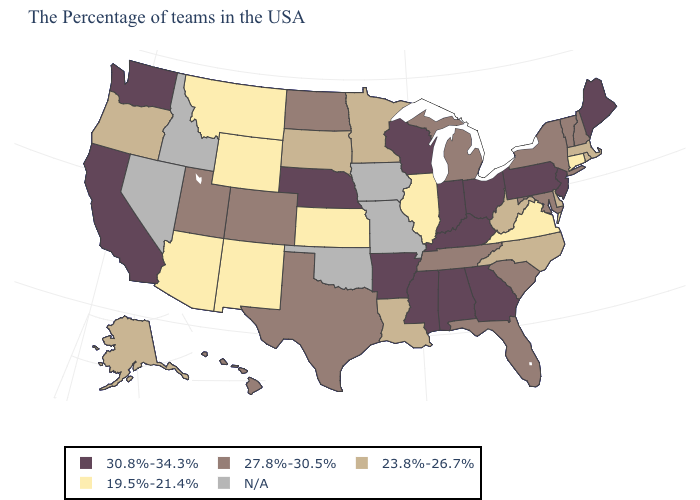What is the highest value in states that border California?
Write a very short answer. 23.8%-26.7%. Among the states that border Wyoming , does Nebraska have the highest value?
Keep it brief. Yes. Does Illinois have the lowest value in the MidWest?
Write a very short answer. Yes. What is the highest value in states that border Colorado?
Give a very brief answer. 30.8%-34.3%. Name the states that have a value in the range N/A?
Short answer required. Missouri, Iowa, Oklahoma, Idaho, Nevada. What is the highest value in the USA?
Answer briefly. 30.8%-34.3%. Does Illinois have the lowest value in the MidWest?
Give a very brief answer. Yes. Does the map have missing data?
Give a very brief answer. Yes. Among the states that border New Jersey , which have the lowest value?
Concise answer only. Delaware. Among the states that border Kentucky , which have the lowest value?
Keep it brief. Virginia, Illinois. What is the lowest value in states that border Arizona?
Keep it brief. 19.5%-21.4%. Name the states that have a value in the range 23.8%-26.7%?
Keep it brief. Massachusetts, Rhode Island, Delaware, North Carolina, West Virginia, Louisiana, Minnesota, South Dakota, Oregon, Alaska. Name the states that have a value in the range 30.8%-34.3%?
Be succinct. Maine, New Jersey, Pennsylvania, Ohio, Georgia, Kentucky, Indiana, Alabama, Wisconsin, Mississippi, Arkansas, Nebraska, California, Washington. 